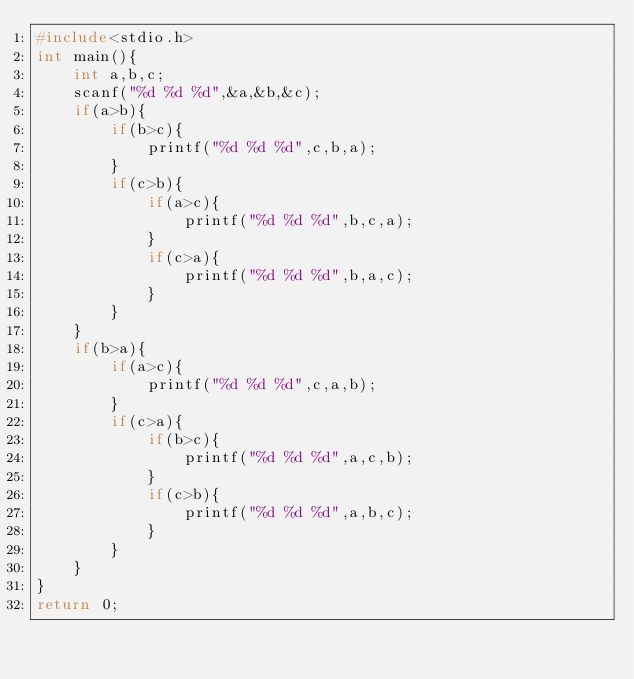Convert code to text. <code><loc_0><loc_0><loc_500><loc_500><_C_>#include<stdio.h>
int main(){
	int a,b,c;
	scanf("%d %d %d",&a,&b,&c);
	if(a>b){
		if(b>c){
			printf("%d %d %d",c,b,a);
		}
		if(c>b){
			if(a>c){
				printf("%d %d %d",b,c,a);
			}
			if(c>a){
				printf("%d %d %d",b,a,c);
			}
		}
	}
	if(b>a){
		if(a>c){
			printf("%d %d %d",c,a,b);
		}
		if(c>a){
			if(b>c){
				printf("%d %d %d",a,c,b);
			}
			if(c>b){
				printf("%d %d %d",a,b,c);
			}
		}
	}	
}			
return 0;</code> 